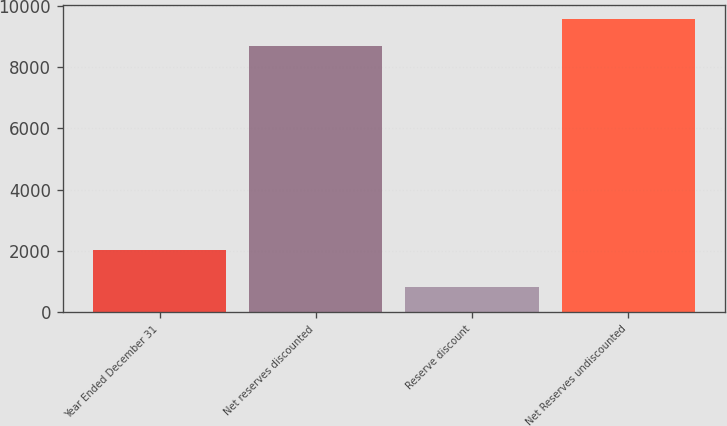<chart> <loc_0><loc_0><loc_500><loc_500><bar_chart><fcel>Year Ended December 31<fcel>Net reserves discounted<fcel>Reserve discount<fcel>Net Reserves undiscounted<nl><fcel>2013<fcel>8684<fcel>837<fcel>9552.4<nl></chart> 